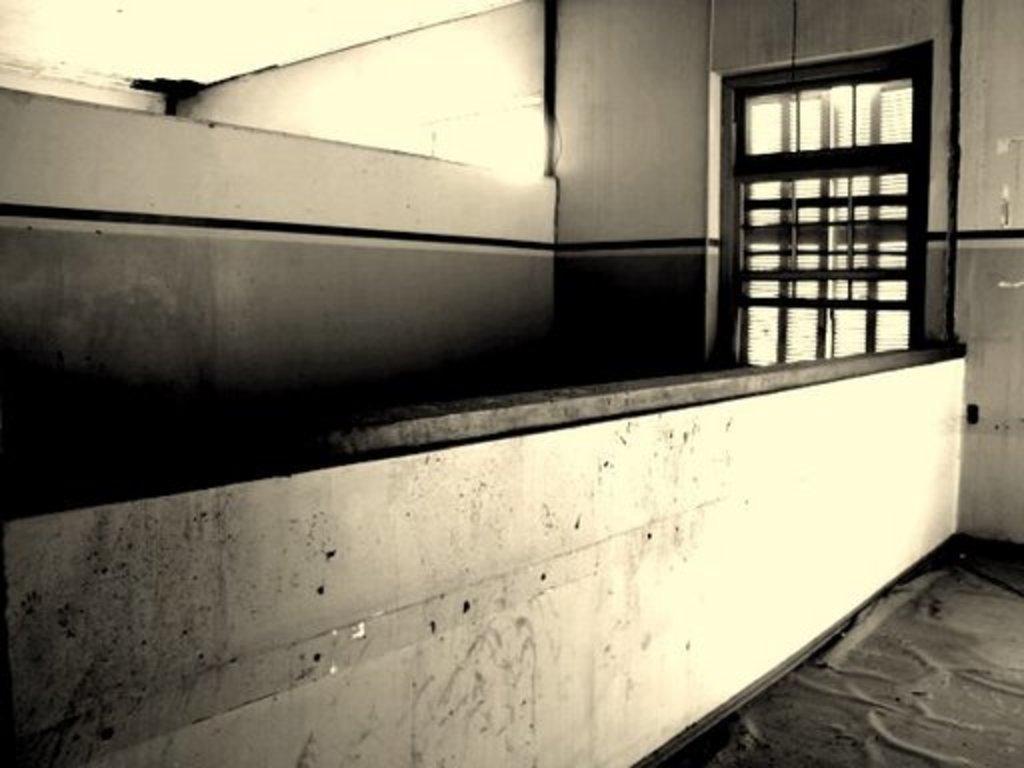Please provide a concise description of this image. In this picture we can see wall, on the right side of the image we can see a window. 